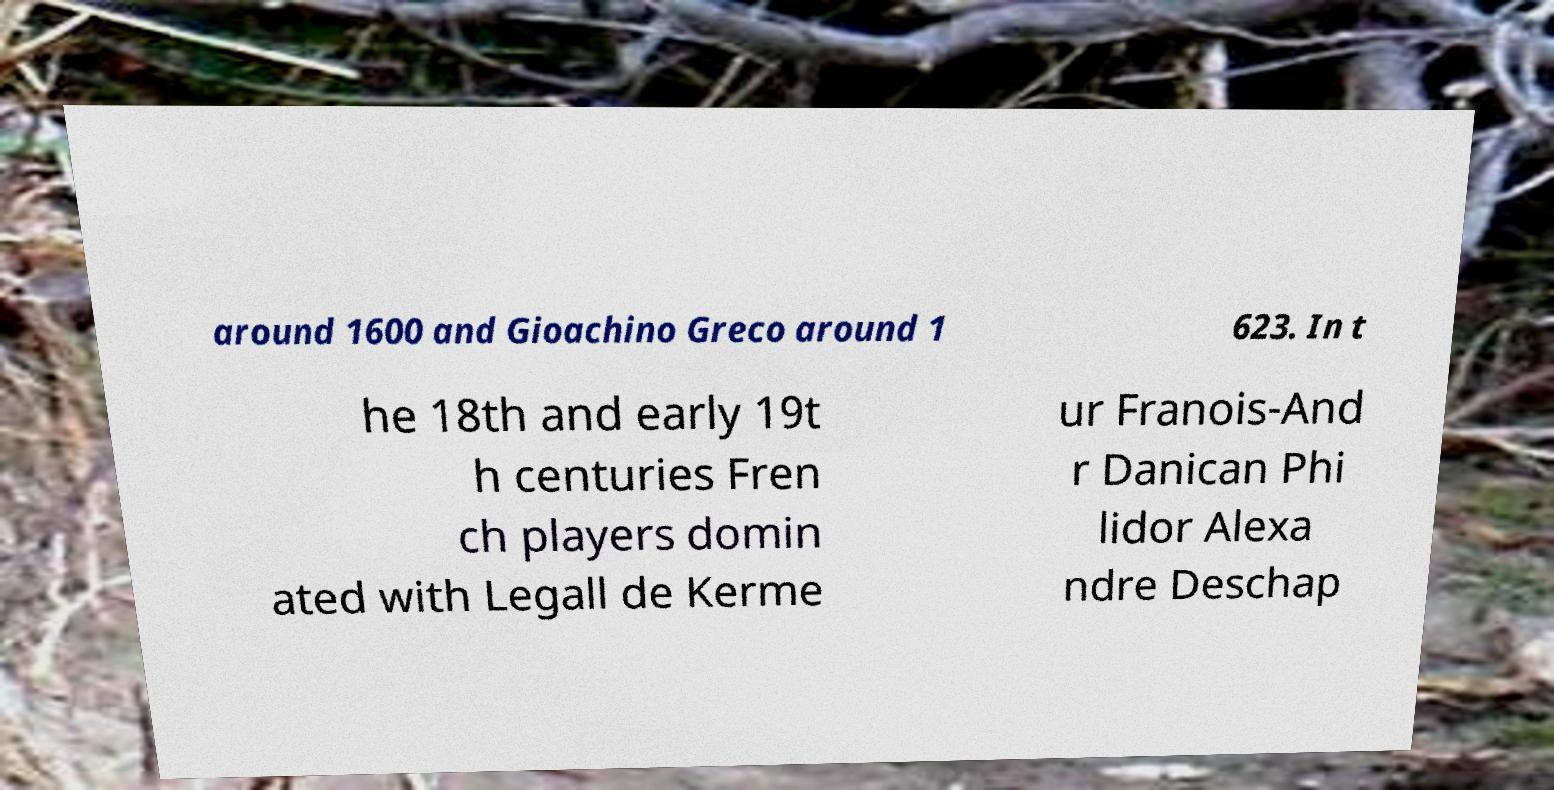There's text embedded in this image that I need extracted. Can you transcribe it verbatim? around 1600 and Gioachino Greco around 1 623. In t he 18th and early 19t h centuries Fren ch players domin ated with Legall de Kerme ur Franois-And r Danican Phi lidor Alexa ndre Deschap 